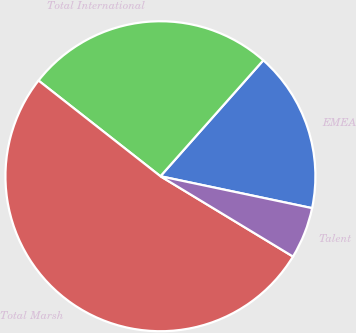<chart> <loc_0><loc_0><loc_500><loc_500><pie_chart><fcel>EMEA<fcel>Total International<fcel>Total Marsh<fcel>Talent<nl><fcel>16.75%<fcel>25.96%<fcel>51.92%<fcel>5.37%<nl></chart> 